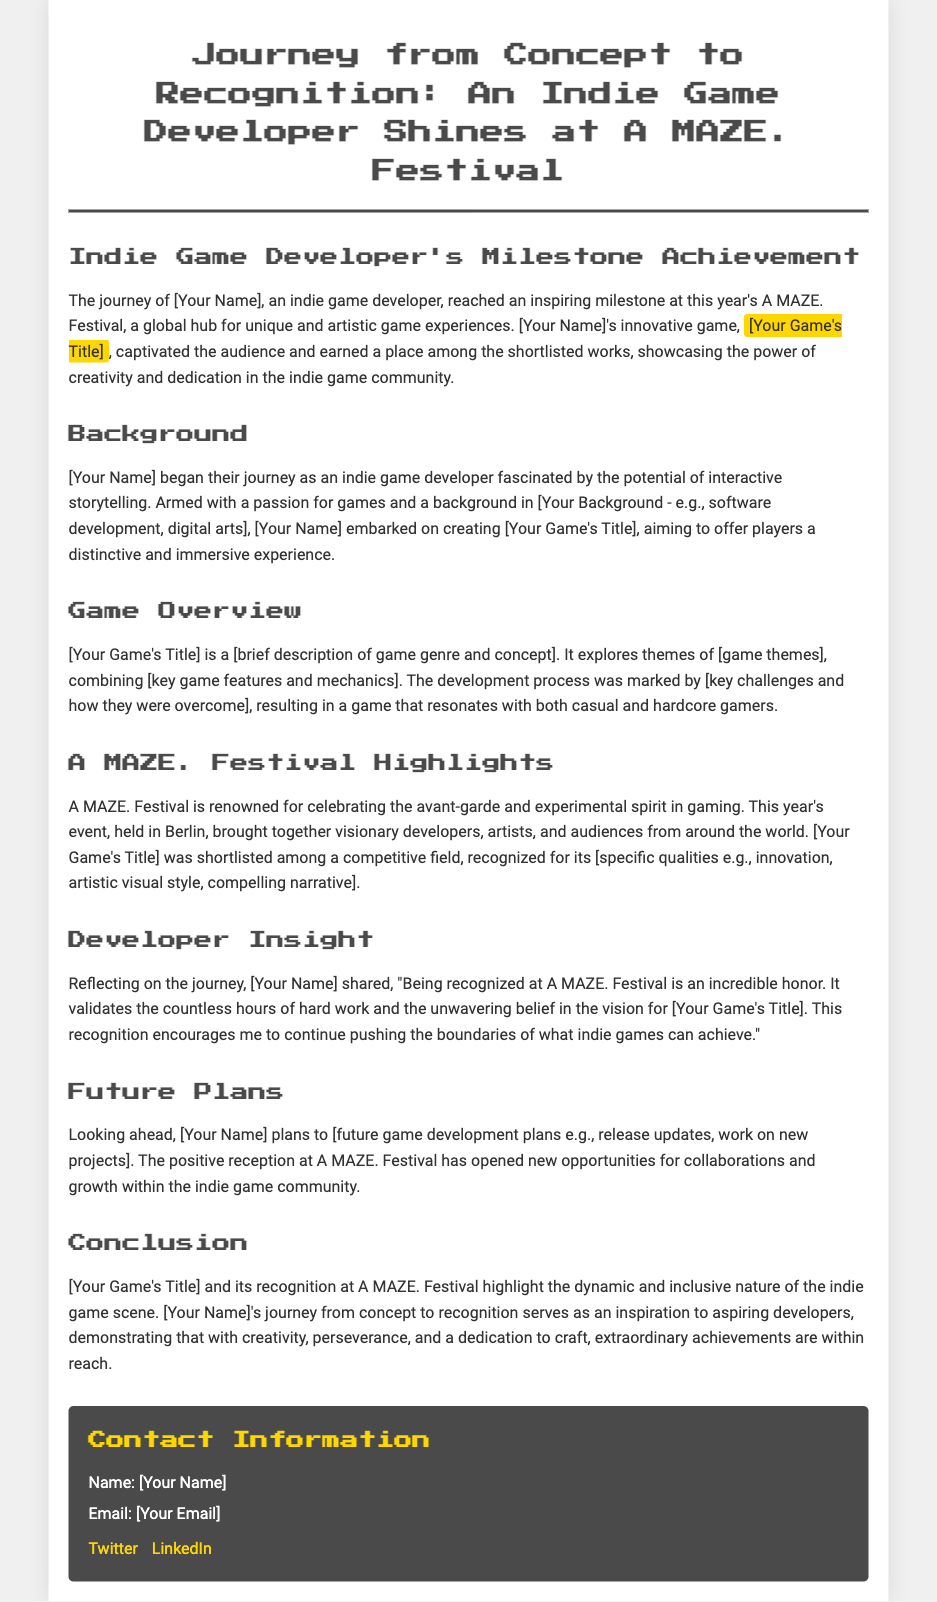What is the name of the festival where the game was recognized? The name of the festival where the game was recognized is mentioned in the title of the document and various places in the text.
Answer: A MAZE. Festival Who is the indie game developer mentioned in the document? The document refers to the developer as [Your Name].
Answer: [Your Name] What is the title of the game that was shortlisted? The title of the game is highlighted in the text and indicated as [Your Game's Title].
Answer: [Your Game's Title] What city hosted the A MAZE. Festival this year? The location of the festival is provided in the section discussing the festival highlights.
Answer: Berlin What type of recognition did the game receive at A MAZE. Festival? The document states that the game was shortlisted at the festival, which indicates a form of recognition.
Answer: Shortlisted What theme does the game explore, as mentioned in the document? The themes of the game are discussed in the game overview section but are indicated as [game themes].
Answer: [game themes] What does the developer plan to do after the festival? The document discusses future plans of the developer and indicates that they have specific intentions moving forward.
Answer: [future game development plans] What is a key quality of [Your Game's Title] that contributed to its recognition? The document explains that the game was recognized for specific qualities in the festival highlights section.
Answer: [specific qualities e.g., innovation, artistic visual style, compelling narrative] How does the developer feel about the recognition? The developer's feelings are expressed in a direct quote in the document.
Answer: Incredible honor 